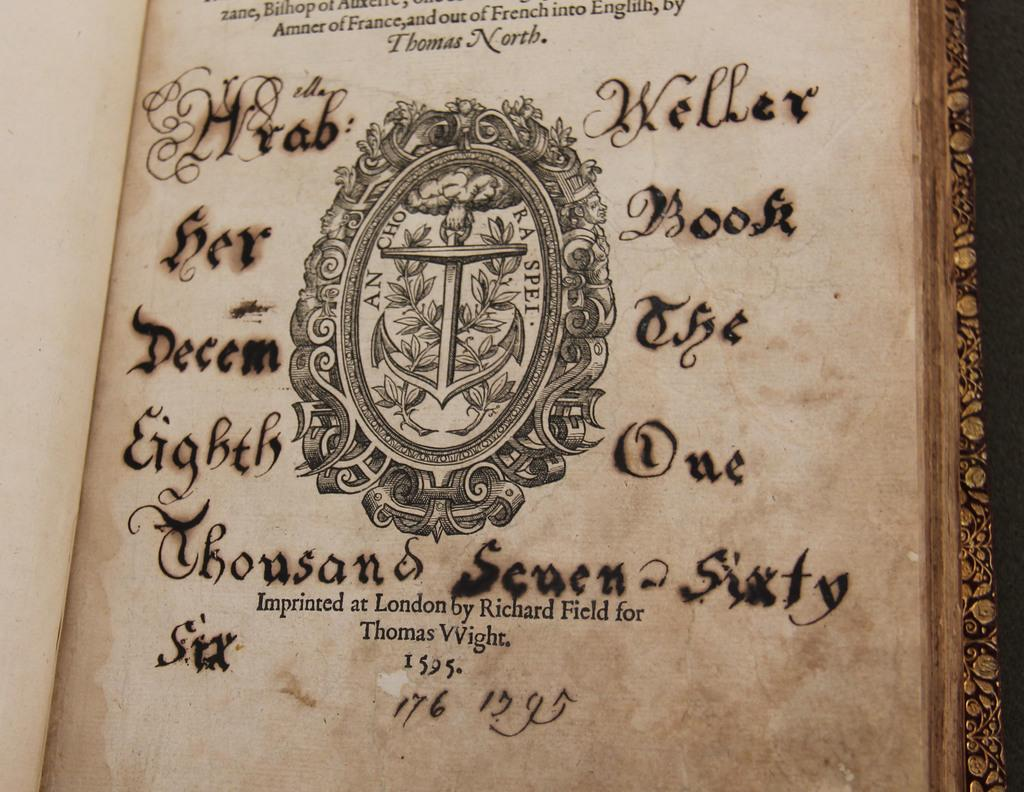<image>
Give a short and clear explanation of the subsequent image. The inside cover of a book imprinted at London by Richard Field for Thomas Wight. 